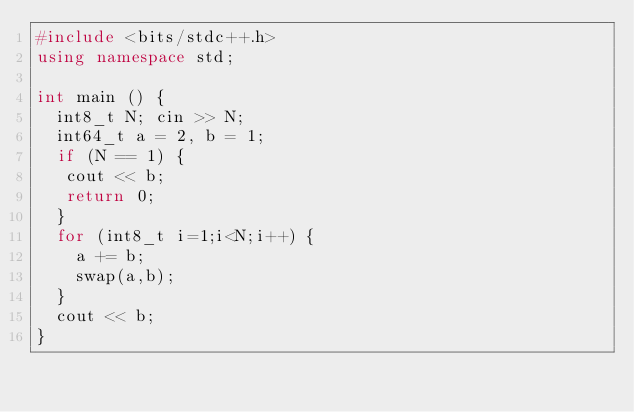<code> <loc_0><loc_0><loc_500><loc_500><_C++_>#include <bits/stdc++.h>
using namespace std;

int main () {
  int8_t N; cin >> N;
  int64_t a = 2, b = 1;
  if (N == 1) {
   cout << b;
   return 0;
  }
  for (int8_t i=1;i<N;i++) {
    a += b;
    swap(a,b);
  }
  cout << b;
}
</code> 